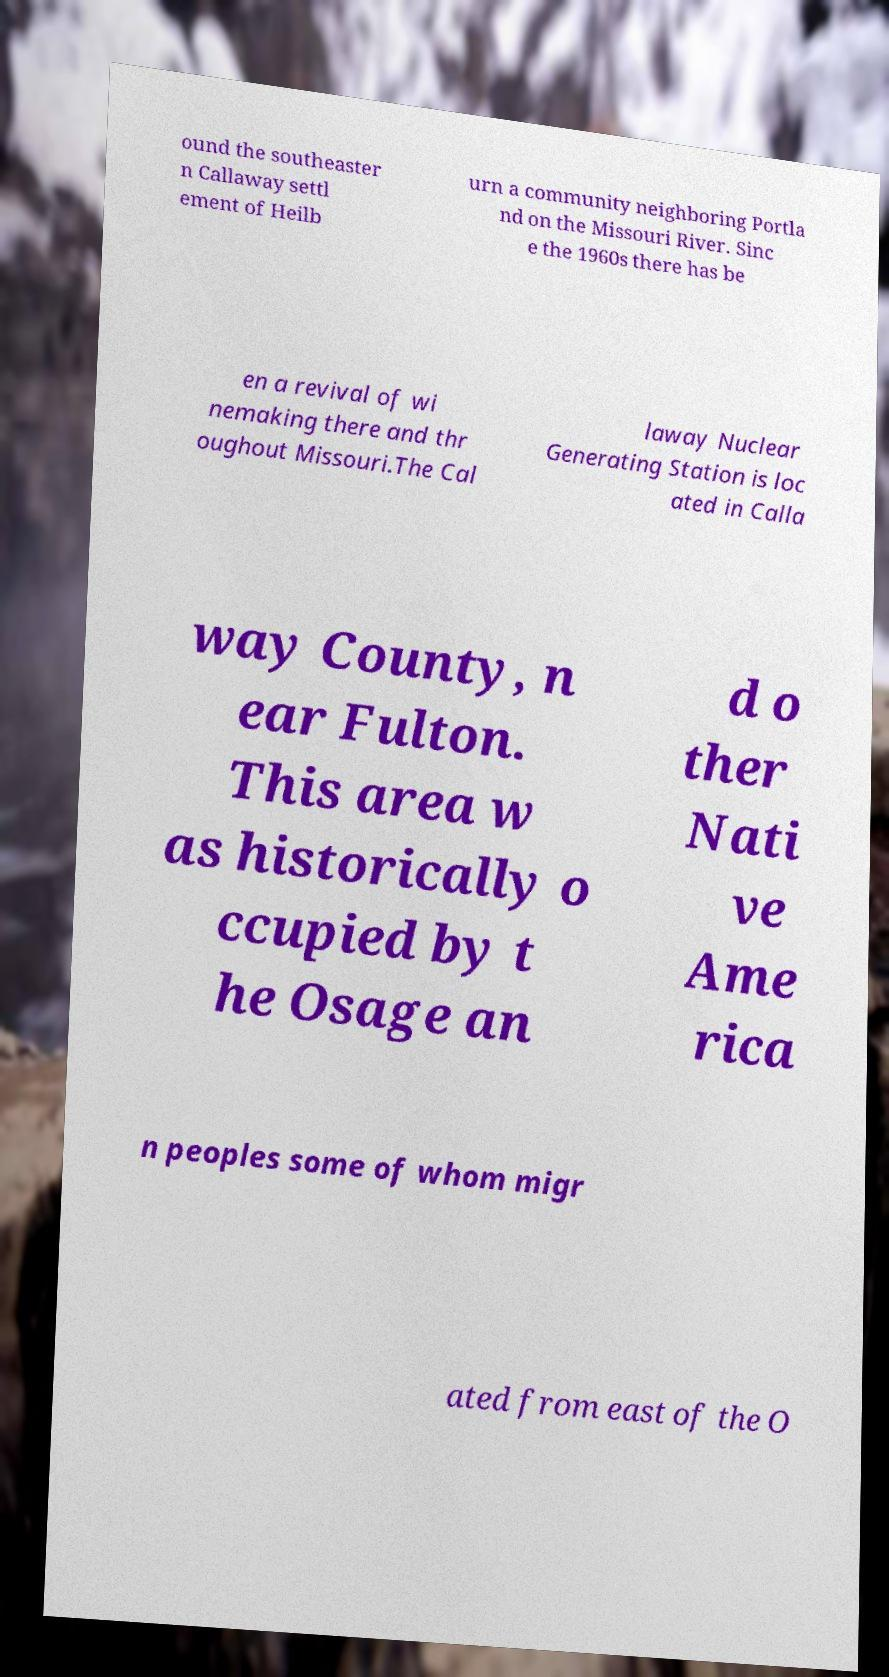Could you extract and type out the text from this image? ound the southeaster n Callaway settl ement of Heilb urn a community neighboring Portla nd on the Missouri River. Sinc e the 1960s there has be en a revival of wi nemaking there and thr oughout Missouri.The Cal laway Nuclear Generating Station is loc ated in Calla way County, n ear Fulton. This area w as historically o ccupied by t he Osage an d o ther Nati ve Ame rica n peoples some of whom migr ated from east of the O 